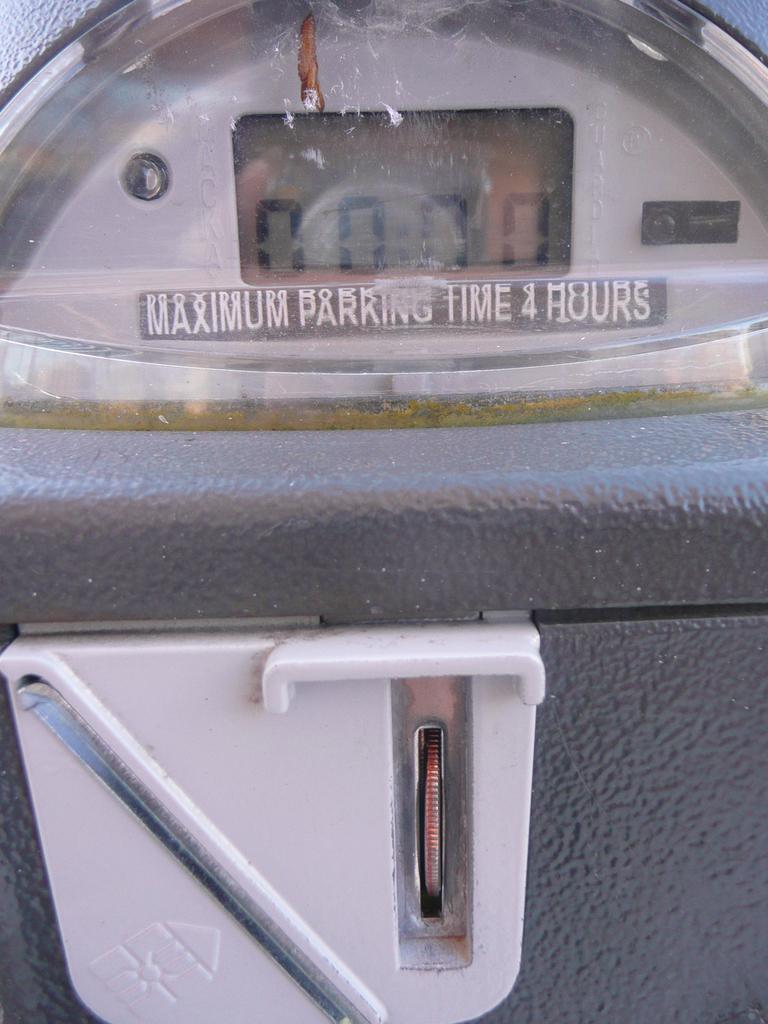Describe this image in one or two sentences. In this picture we see a machine which provides ticket for a vehicle parking. 